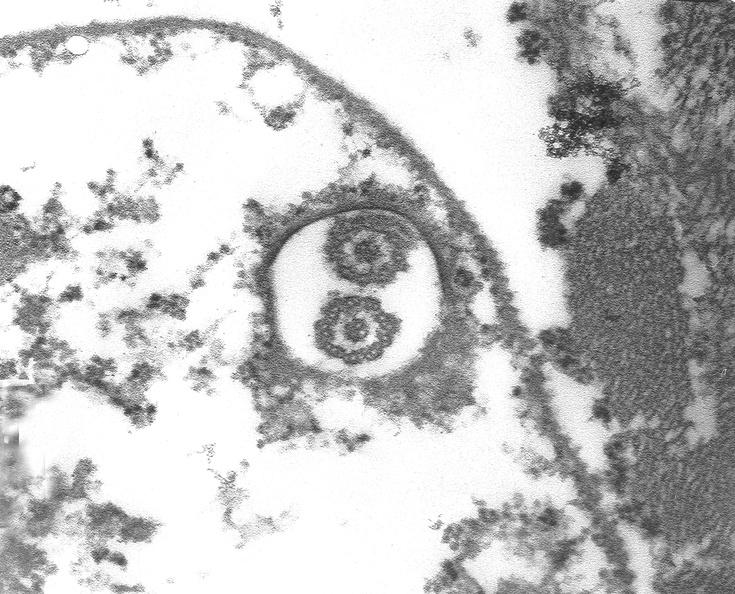what does this image show?
Answer the question using a single word or phrase. Chagas disease 